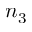Convert formula to latex. <formula><loc_0><loc_0><loc_500><loc_500>n _ { 3 }</formula> 